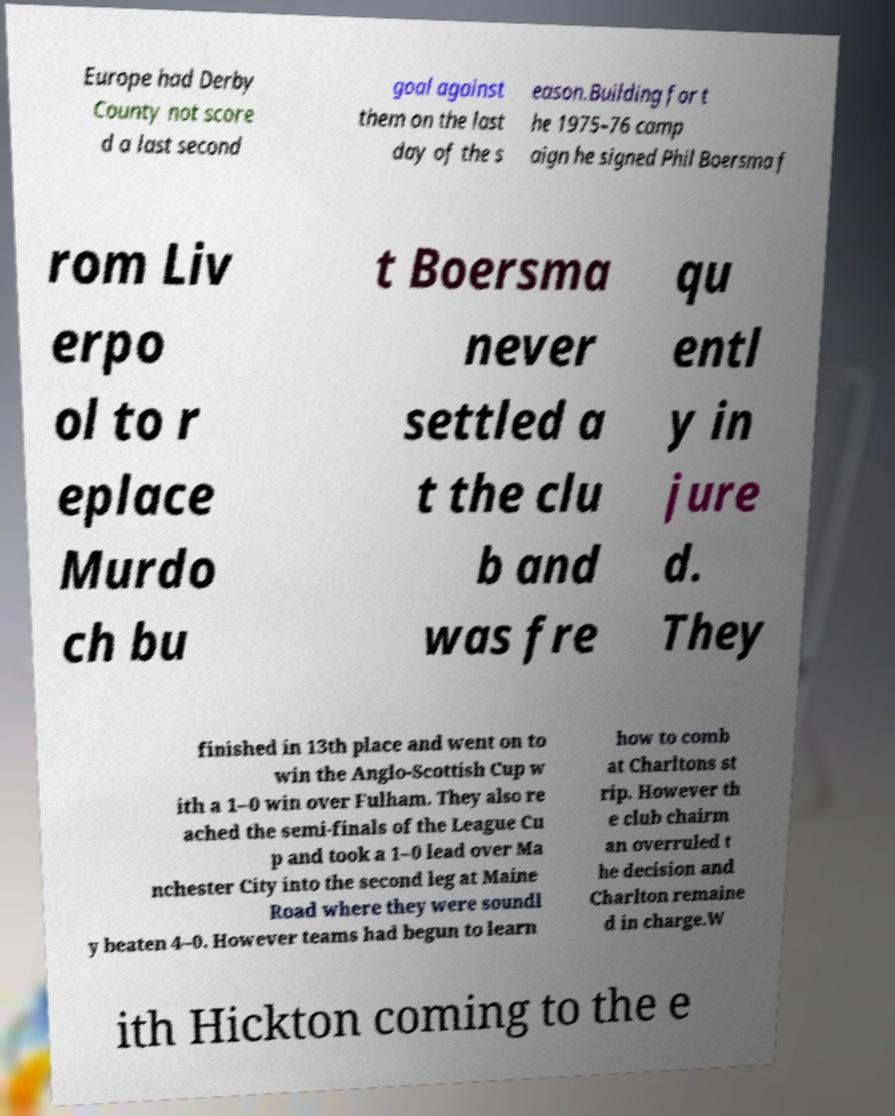Can you read and provide the text displayed in the image?This photo seems to have some interesting text. Can you extract and type it out for me? Europe had Derby County not score d a last second goal against them on the last day of the s eason.Building for t he 1975–76 camp aign he signed Phil Boersma f rom Liv erpo ol to r eplace Murdo ch bu t Boersma never settled a t the clu b and was fre qu entl y in jure d. They finished in 13th place and went on to win the Anglo-Scottish Cup w ith a 1–0 win over Fulham. They also re ached the semi-finals of the League Cu p and took a 1–0 lead over Ma nchester City into the second leg at Maine Road where they were soundl y beaten 4–0. However teams had begun to learn how to comb at Charltons st rip. However th e club chairm an overruled t he decision and Charlton remaine d in charge.W ith Hickton coming to the e 